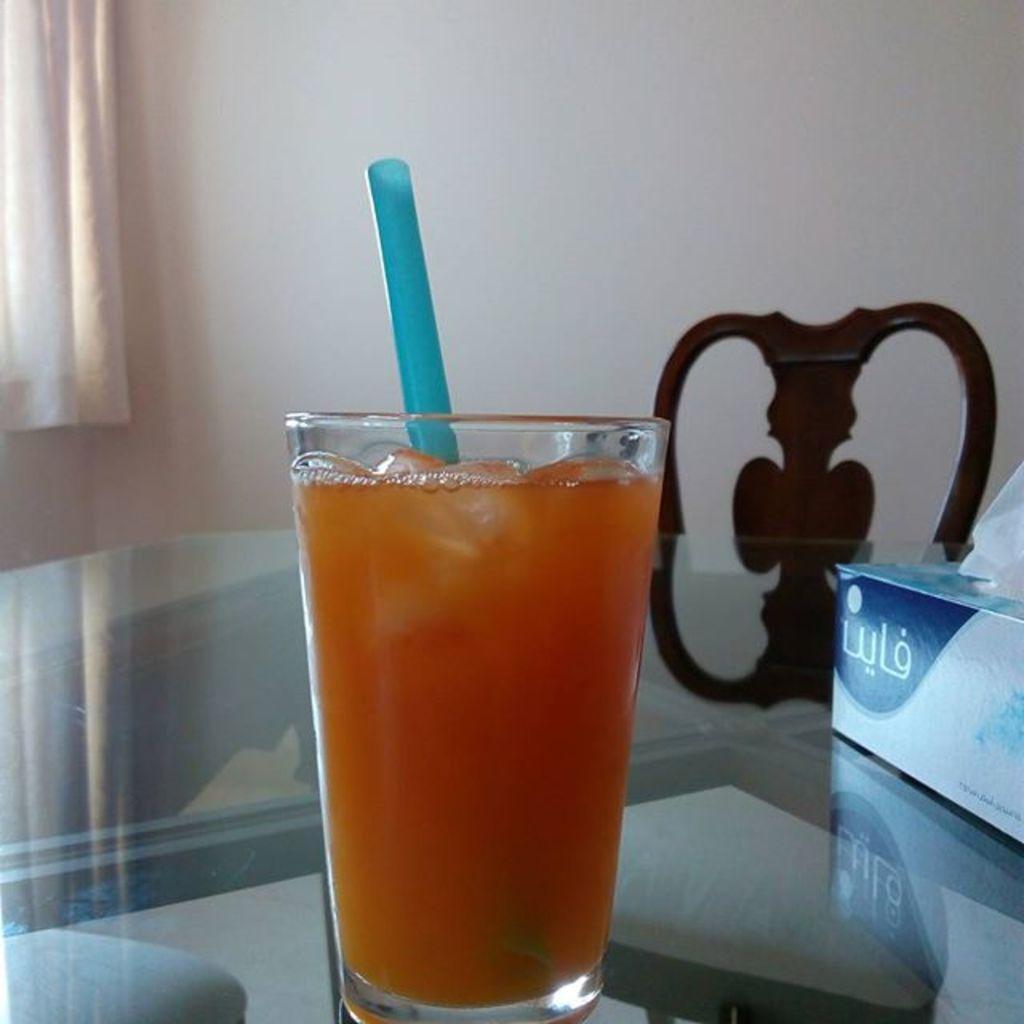Describe this image in one or two sentences. In this image at the bottom there is a table, on the table there is one tissue box, glass, and in the glass there is straw and some drink. In the background there is wall and chair, on the left side there is curtain. 